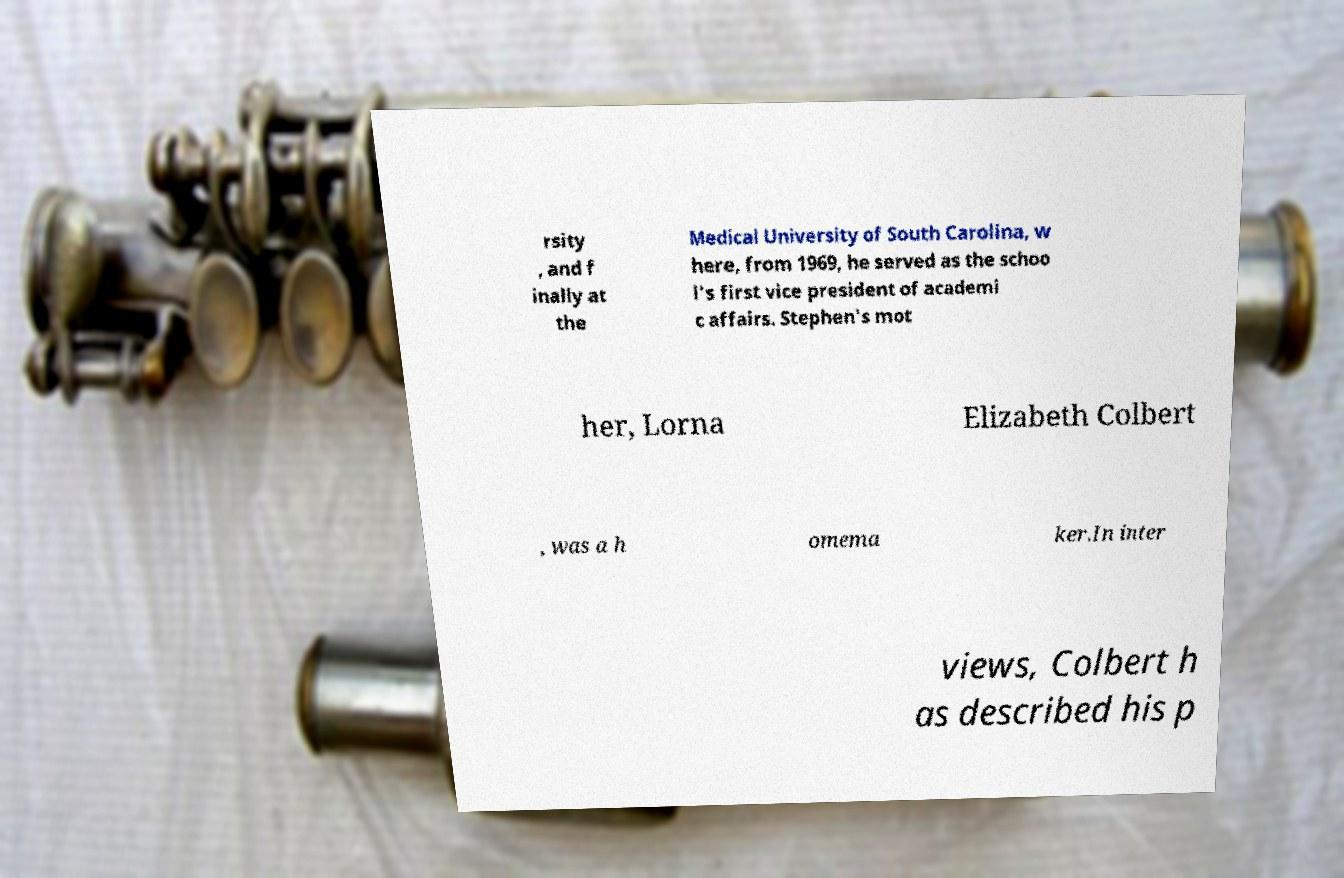Can you accurately transcribe the text from the provided image for me? rsity , and f inally at the Medical University of South Carolina, w here, from 1969, he served as the schoo l's first vice president of academi c affairs. Stephen's mot her, Lorna Elizabeth Colbert , was a h omema ker.In inter views, Colbert h as described his p 